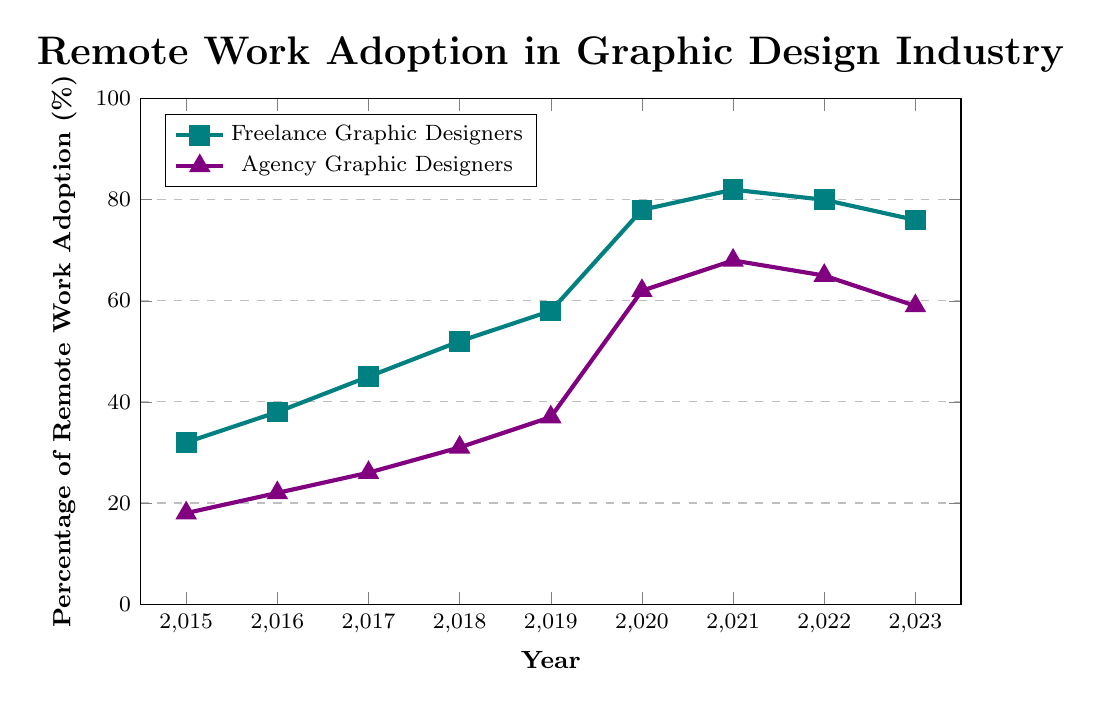What year did freelance graphic designers see the biggest increase in remote work adoption? Look for the year-to-year changes in the percentage of remote work adoption among freelance graphic designers. The largest increase occurred between 2019 and 2020, when it jumped from 58% to 78%.
Answer: 2020 How much did remote work adoption among agency graphic designers increase from 2015 to 2023? Note the percentages for agency graphic designers in 2015 (18%) and 2023 (59%) and then calculate the difference: 59% - 18% = 41%.
Answer: 41% Which group had a higher percentage of remote work adoption in 2017? Compare the percentages for freelance graphic designers (45%) and agency graphic designers (26%) in 2017. Freelance graphic designers had a higher percentage.
Answer: Freelance graphic designers In what year did agency graphic designers reach over 60% remote work adoption? Find the first year where the percentage for agency graphic designers exceeds 60%. This occurs in 2020 at 62%.
Answer: 2020 What is the average percentage of remote work adoption for freelance graphic designers from 2015 to 2023? Add all the percentages for freelance graphic designers from 2015 to 2023 and divide by the number of years: (32 + 38 + 45 + 52 + 58 + 78 + 82 + 80 + 76) / 9 = 59
Answer: 59 Comparing 2022 to 2023, which group showed a larger decline in remote work adoption percentage? Calculate the differences for each group from 2022 to 2023. For freelance graphic designers: 80% - 76% = 4%. For agency graphic designers: 65% - 59% = 6%. Agency graphic designers showed a larger decline.
Answer: Agency graphic designers What color represents freelance graphic designers in the figure? Identify the color of the line associated with freelance graphic designers in the chart. The line for freelance graphic designers is represented by a teal color.
Answer: Teal How many years did it take for freelance graphic designers to reach over 50% remote work adoption? Find the year when freelance graphic designers surpassed 50% (2018) and subtract the starting year 2015: 2018 - 2015 = 3 years.
Answer: 3 What year saw a significant increase in remote work adoption for both groups? Identify the year where both groups had a noticeable increase in their percentages. In 2020, both freelance graphic designers (78%) and agency graphic designers (62%) saw significant jumps in adoption.
Answer: 2020 Did freelance or agency graphic designers see a more stable trend in remote work adoption from 2020 to 2023? Compare the percentage changes from 2020 to 2023 for both groups. Freelance graphic designers decreased from 78% to 76%, varying less compared to agency graphic designers who decreased from 62% to 59%.
Answer: Freelance graphic designers 